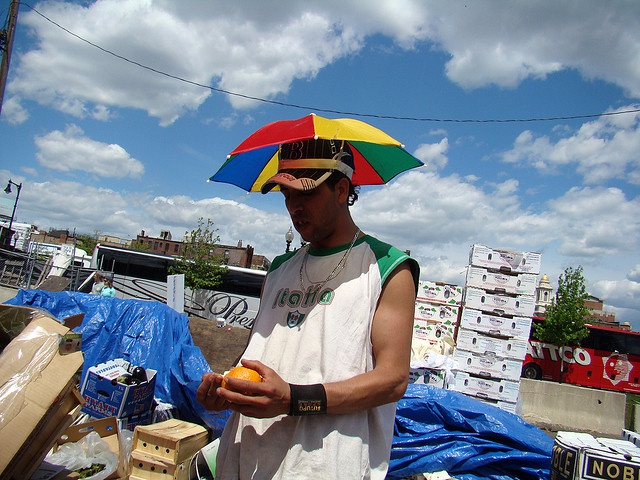Describe the objects in this image and their specific colors. I can see people in blue, lightgray, gray, and black tones, umbrella in blue, brown, darkgreen, and gold tones, bus in blue, black, maroon, and gray tones, bus in blue, black, white, darkgray, and gray tones, and orange in blue, orange, maroon, and black tones in this image. 